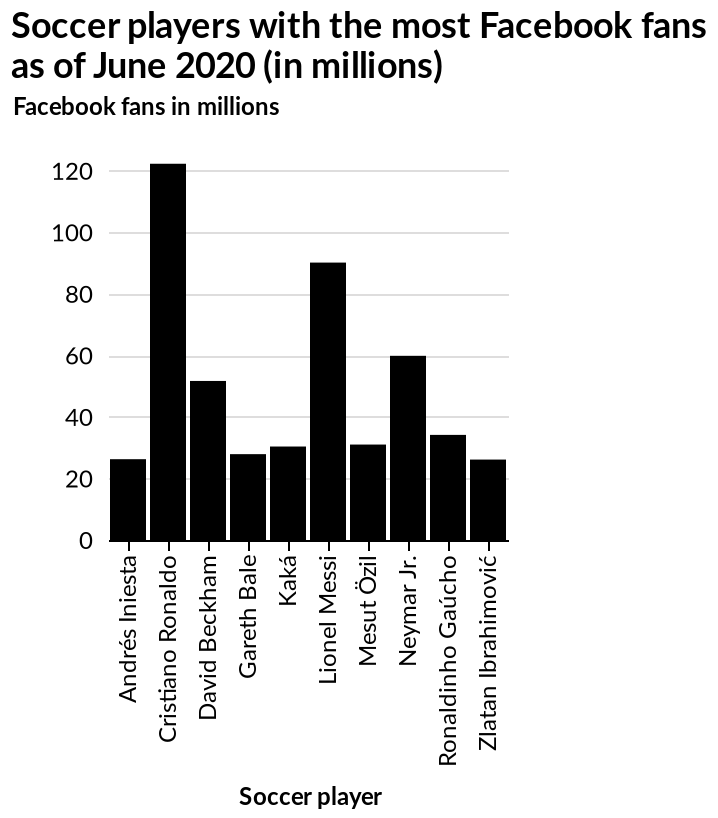<image>
How many players scored 30 goals or less? There are multiple players who scored 30 goals or less, but the specific number is unknown. Who has the lowest number of Facebook fans among the soccer players? Andrés Iniesta has the lowest number of Facebook fans among the soccer players. How many goals did Neymar score?  Neymar scored 60 goals. Does Andrés Iniesta have the highest number of Facebook fans among the soccer players? No.Andrés Iniesta has the lowest number of Facebook fans among the soccer players. 